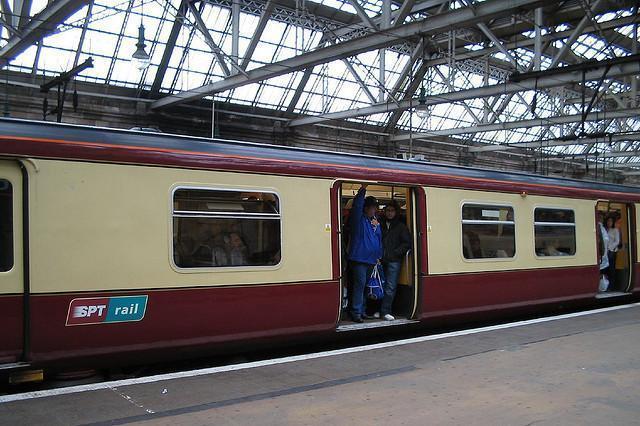How many people can you see?
Give a very brief answer. 2. 